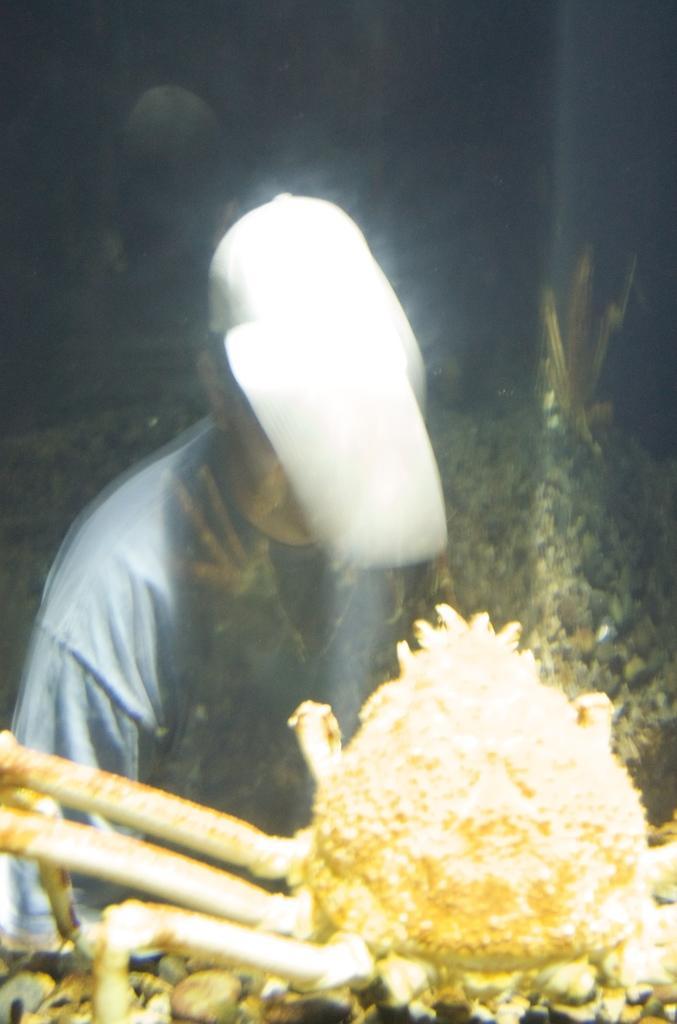Can you describe this image briefly? In this image we can see a crab places in the water. On the backside we can see a person. 